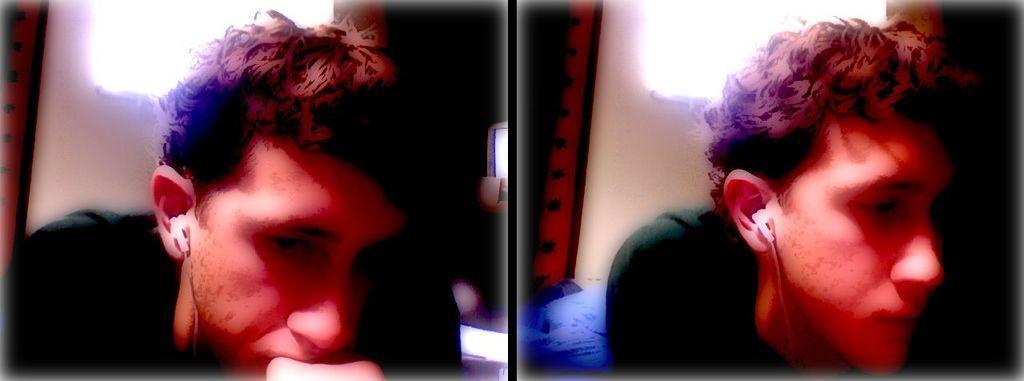Describe this image in one or two sentences. This is a collage of two images where we can see the person on the left side of this image and the same image is on the right side of this image. 